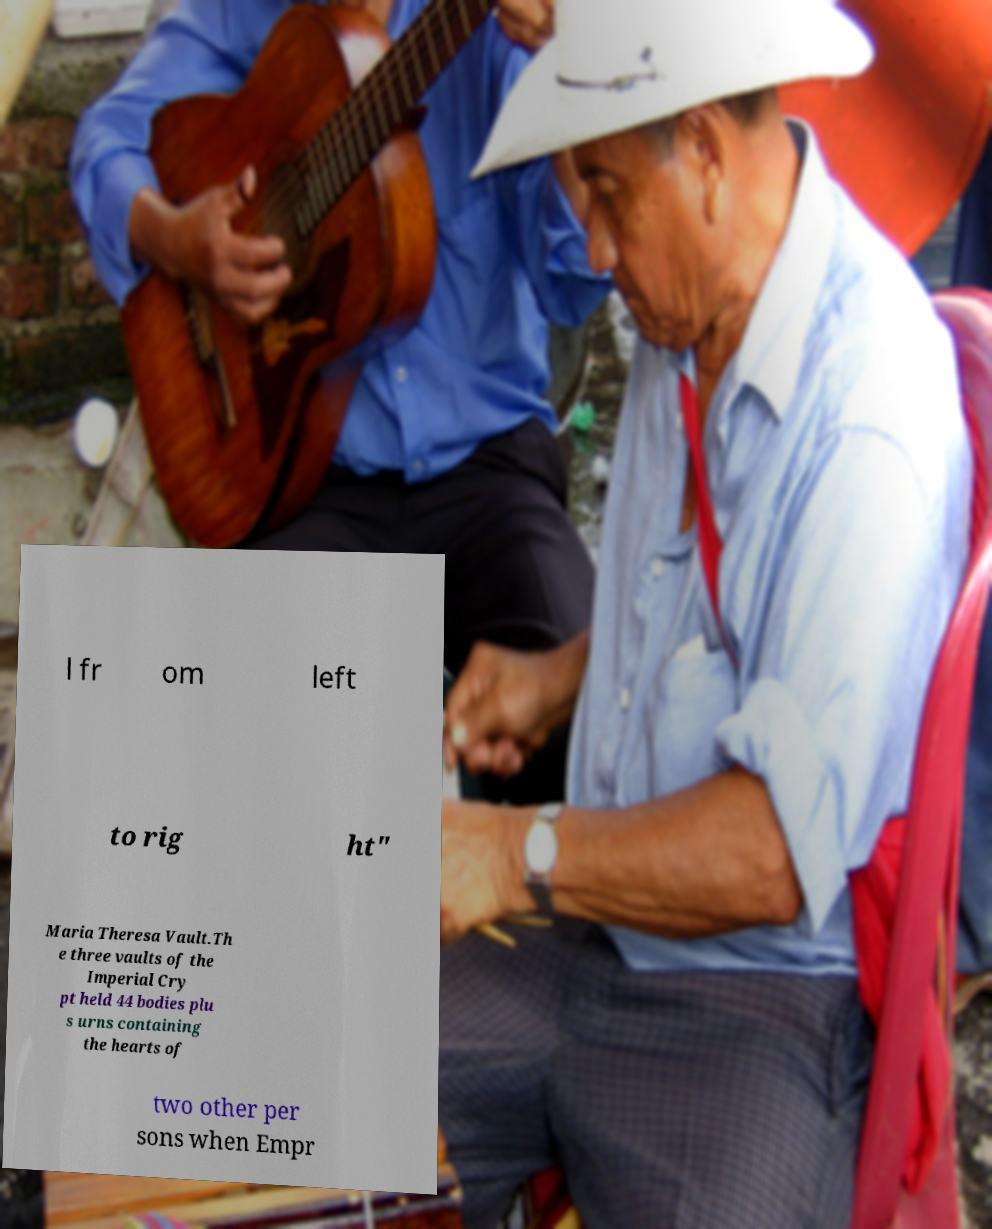What messages or text are displayed in this image? I need them in a readable, typed format. l fr om left to rig ht" Maria Theresa Vault.Th e three vaults of the Imperial Cry pt held 44 bodies plu s urns containing the hearts of two other per sons when Empr 